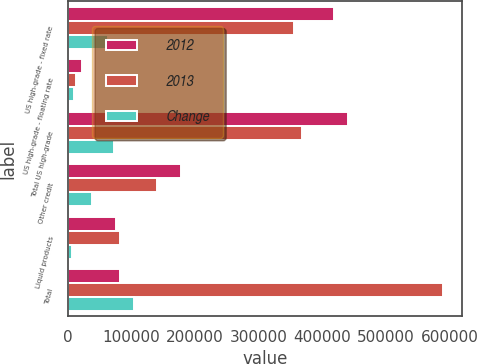Convert chart. <chart><loc_0><loc_0><loc_500><loc_500><stacked_bar_chart><ecel><fcel>US high-grade - fixed rate<fcel>US high-grade - floating rate<fcel>Total US high-grade<fcel>Other credit<fcel>Liquid products<fcel>Total<nl><fcel>2012<fcel>418270<fcel>21813<fcel>440083<fcel>177274<fcel>76319<fcel>82380<nl><fcel>2013<fcel>355087<fcel>12603<fcel>367690<fcel>139526<fcel>82380<fcel>589596<nl><fcel>Change<fcel>63183<fcel>9210<fcel>72393<fcel>37748<fcel>6061<fcel>104080<nl></chart> 